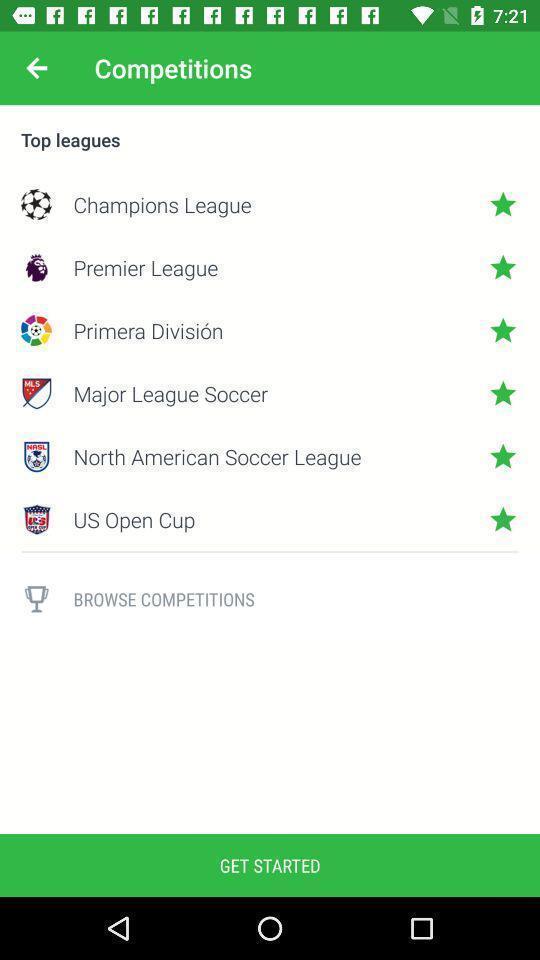Provide a detailed account of this screenshot. Page displays list of top leagues in app. 